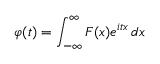<formula> <loc_0><loc_0><loc_500><loc_500>\varphi ( t ) = \int _ { - \infty } ^ { \infty } F ( x ) e ^ { i t x } \, d x</formula> 